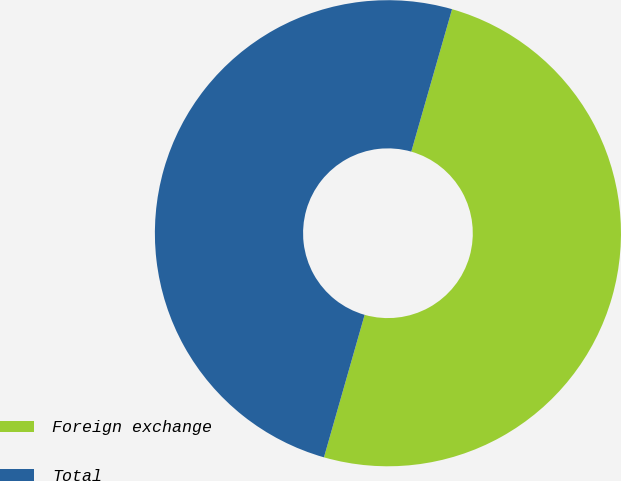Convert chart to OTSL. <chart><loc_0><loc_0><loc_500><loc_500><pie_chart><fcel>Foreign exchange<fcel>Total<nl><fcel>49.99%<fcel>50.01%<nl></chart> 